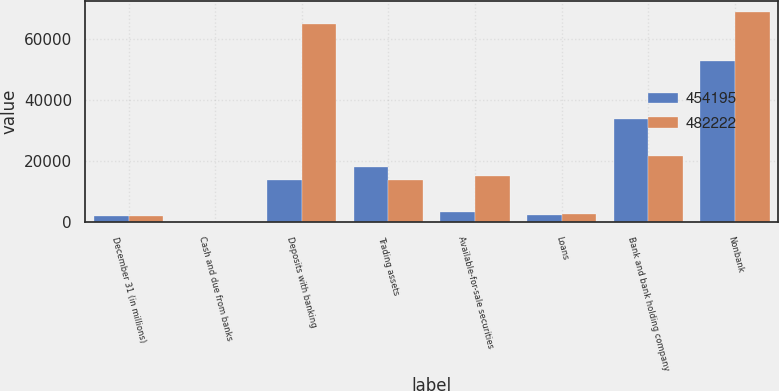<chart> <loc_0><loc_0><loc_500><loc_500><stacked_bar_chart><ecel><fcel>December 31 (in millions)<fcel>Cash and due from banks<fcel>Deposits with banking<fcel>Trading assets<fcel>Available-for-sale securities<fcel>Loans<fcel>Bank and bank holding company<fcel>Nonbank<nl><fcel>454195<fcel>2014<fcel>211<fcel>13727<fcel>18222<fcel>3321<fcel>2260<fcel>33810<fcel>52626<nl><fcel>482222<fcel>2013<fcel>264<fcel>64843<fcel>13727<fcel>15228<fcel>2829<fcel>21693<fcel>68788<nl></chart> 